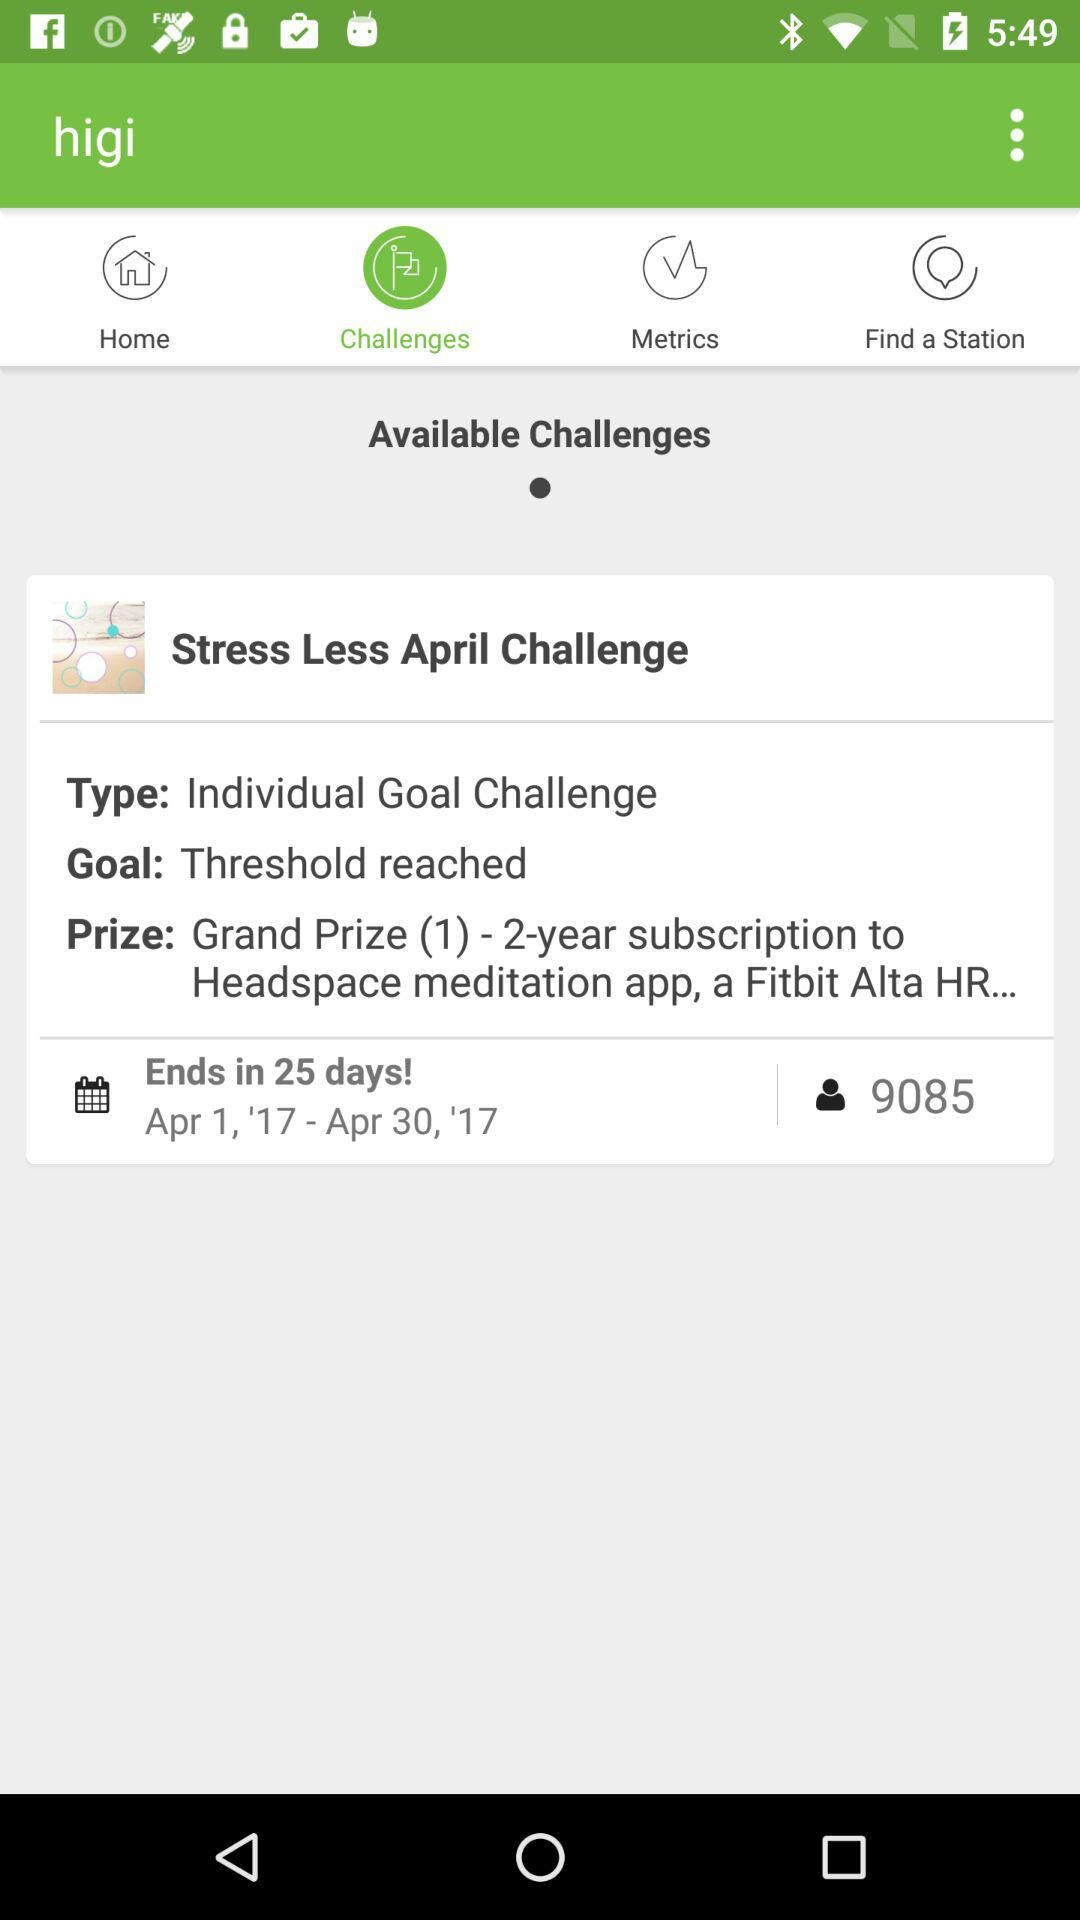What is the challenge type? The challenge type is "Individual Goal Challenge". 